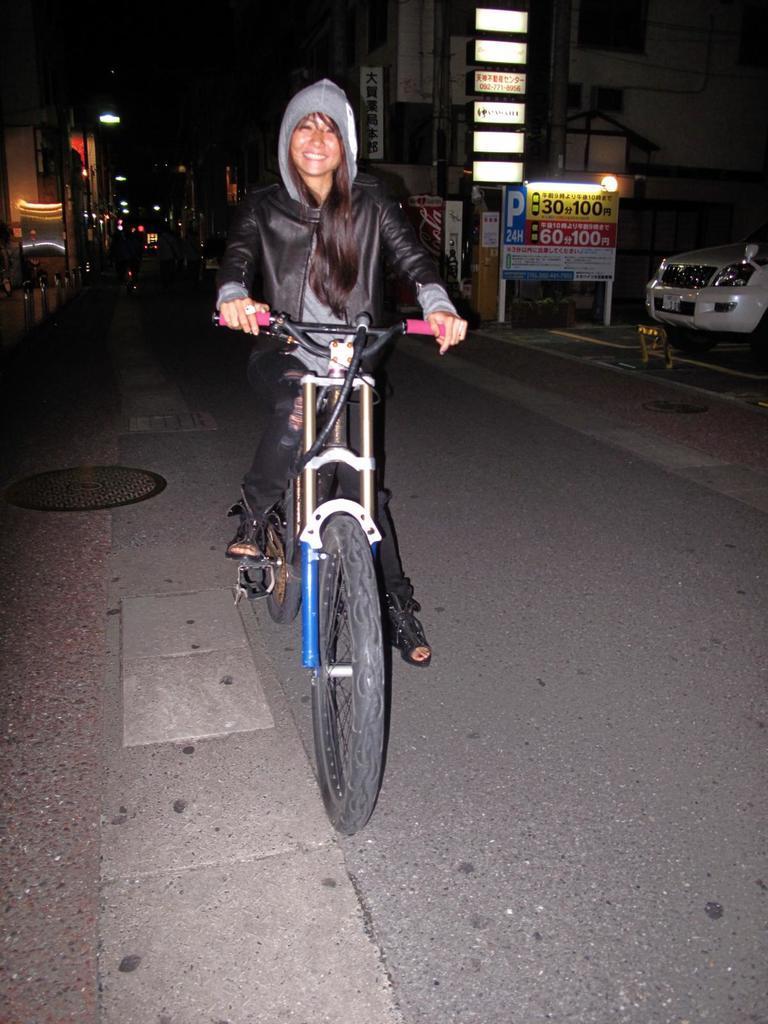Describe this image in one or two sentences. In this image I can see a woman is on her cycle, in the background I can see a vehicle and number of buildings. I can also see a smile on her face. 